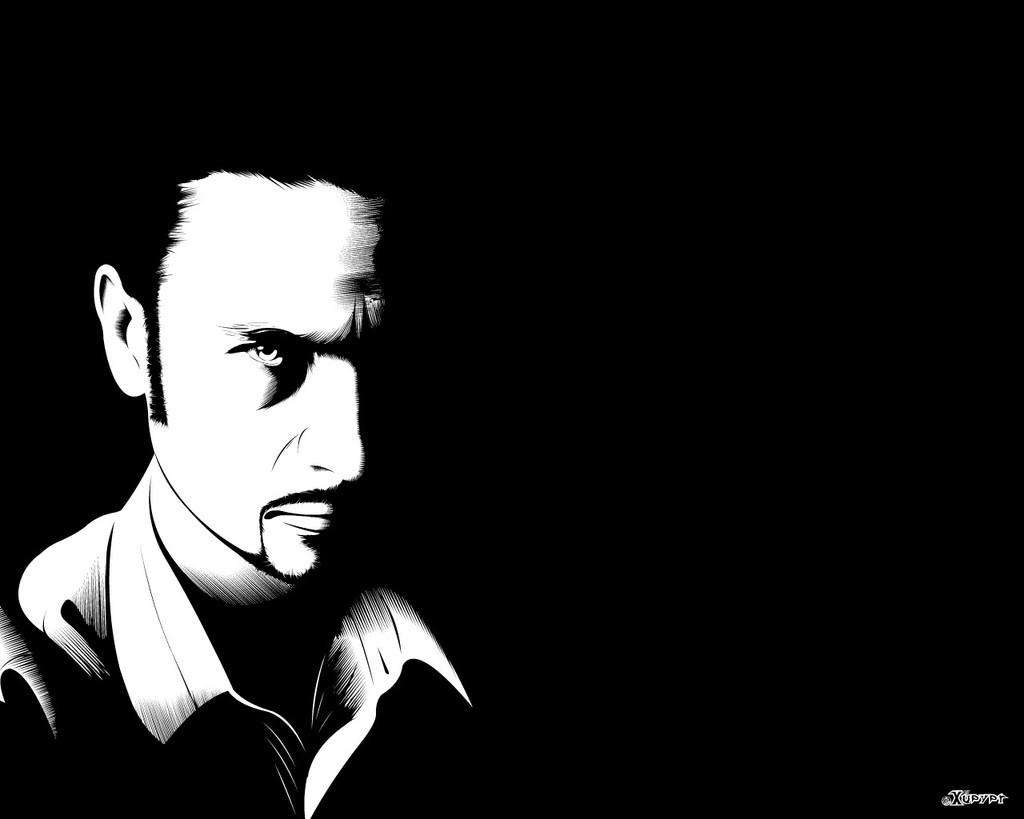Who is present in the image? There is a man in the image. What can be observed about the background of the image? The background of the image is dark. Is there any text visible in the image? Yes, there is text in the bottom right corner of the image. What type of juice is being squeezed by the man in the image? There is no juice or squeezing action present in the image; it only features a man with a dark background and text in the bottom right corner. 